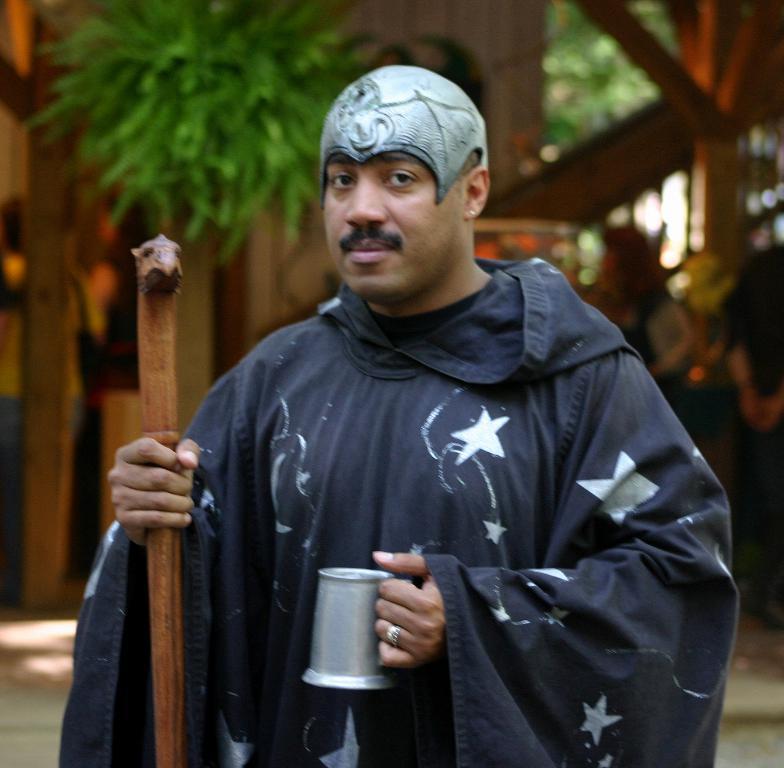How would you summarize this image in a sentence or two? In this image in the center there is one person who is standing and he is holding one mug and stick, in the background there is a house trees and some other persons. 